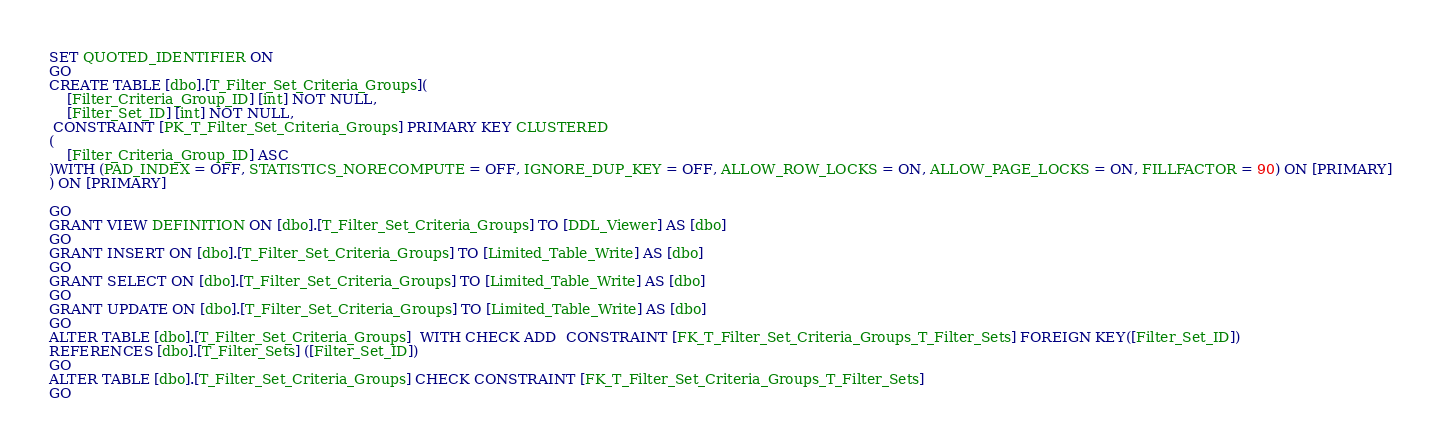Convert code to text. <code><loc_0><loc_0><loc_500><loc_500><_SQL_>SET QUOTED_IDENTIFIER ON
GO
CREATE TABLE [dbo].[T_Filter_Set_Criteria_Groups](
	[Filter_Criteria_Group_ID] [int] NOT NULL,
	[Filter_Set_ID] [int] NOT NULL,
 CONSTRAINT [PK_T_Filter_Set_Criteria_Groups] PRIMARY KEY CLUSTERED 
(
	[Filter_Criteria_Group_ID] ASC
)WITH (PAD_INDEX = OFF, STATISTICS_NORECOMPUTE = OFF, IGNORE_DUP_KEY = OFF, ALLOW_ROW_LOCKS = ON, ALLOW_PAGE_LOCKS = ON, FILLFACTOR = 90) ON [PRIMARY]
) ON [PRIMARY]

GO
GRANT VIEW DEFINITION ON [dbo].[T_Filter_Set_Criteria_Groups] TO [DDL_Viewer] AS [dbo]
GO
GRANT INSERT ON [dbo].[T_Filter_Set_Criteria_Groups] TO [Limited_Table_Write] AS [dbo]
GO
GRANT SELECT ON [dbo].[T_Filter_Set_Criteria_Groups] TO [Limited_Table_Write] AS [dbo]
GO
GRANT UPDATE ON [dbo].[T_Filter_Set_Criteria_Groups] TO [Limited_Table_Write] AS [dbo]
GO
ALTER TABLE [dbo].[T_Filter_Set_Criteria_Groups]  WITH CHECK ADD  CONSTRAINT [FK_T_Filter_Set_Criteria_Groups_T_Filter_Sets] FOREIGN KEY([Filter_Set_ID])
REFERENCES [dbo].[T_Filter_Sets] ([Filter_Set_ID])
GO
ALTER TABLE [dbo].[T_Filter_Set_Criteria_Groups] CHECK CONSTRAINT [FK_T_Filter_Set_Criteria_Groups_T_Filter_Sets]
GO
</code> 